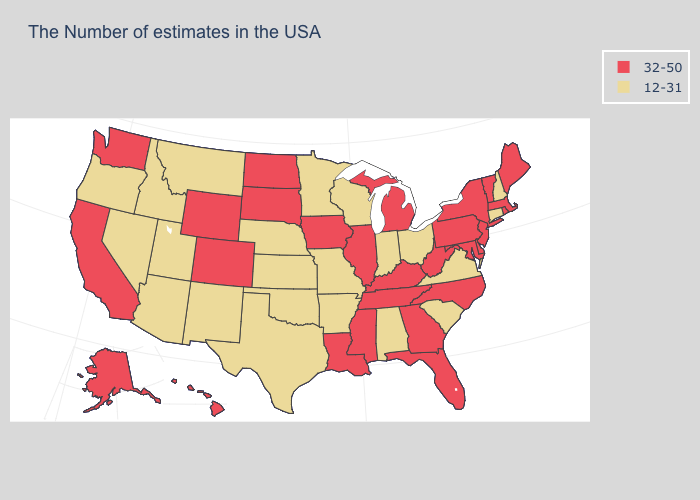Name the states that have a value in the range 12-31?
Quick response, please. New Hampshire, Connecticut, Virginia, South Carolina, Ohio, Indiana, Alabama, Wisconsin, Missouri, Arkansas, Minnesota, Kansas, Nebraska, Oklahoma, Texas, New Mexico, Utah, Montana, Arizona, Idaho, Nevada, Oregon. How many symbols are there in the legend?
Give a very brief answer. 2. Name the states that have a value in the range 12-31?
Answer briefly. New Hampshire, Connecticut, Virginia, South Carolina, Ohio, Indiana, Alabama, Wisconsin, Missouri, Arkansas, Minnesota, Kansas, Nebraska, Oklahoma, Texas, New Mexico, Utah, Montana, Arizona, Idaho, Nevada, Oregon. How many symbols are there in the legend?
Short answer required. 2. Name the states that have a value in the range 32-50?
Keep it brief. Maine, Massachusetts, Rhode Island, Vermont, New York, New Jersey, Delaware, Maryland, Pennsylvania, North Carolina, West Virginia, Florida, Georgia, Michigan, Kentucky, Tennessee, Illinois, Mississippi, Louisiana, Iowa, South Dakota, North Dakota, Wyoming, Colorado, California, Washington, Alaska, Hawaii. Among the states that border Pennsylvania , which have the lowest value?
Keep it brief. Ohio. Among the states that border Georgia , which have the lowest value?
Write a very short answer. South Carolina, Alabama. How many symbols are there in the legend?
Answer briefly. 2. Does South Carolina have the lowest value in the USA?
Write a very short answer. Yes. What is the value of Connecticut?
Keep it brief. 12-31. Does the map have missing data?
Quick response, please. No. Which states have the lowest value in the USA?
Answer briefly. New Hampshire, Connecticut, Virginia, South Carolina, Ohio, Indiana, Alabama, Wisconsin, Missouri, Arkansas, Minnesota, Kansas, Nebraska, Oklahoma, Texas, New Mexico, Utah, Montana, Arizona, Idaho, Nevada, Oregon. Does South Carolina have a lower value than Utah?
Keep it brief. No. Does Oregon have the highest value in the West?
Quick response, please. No. 